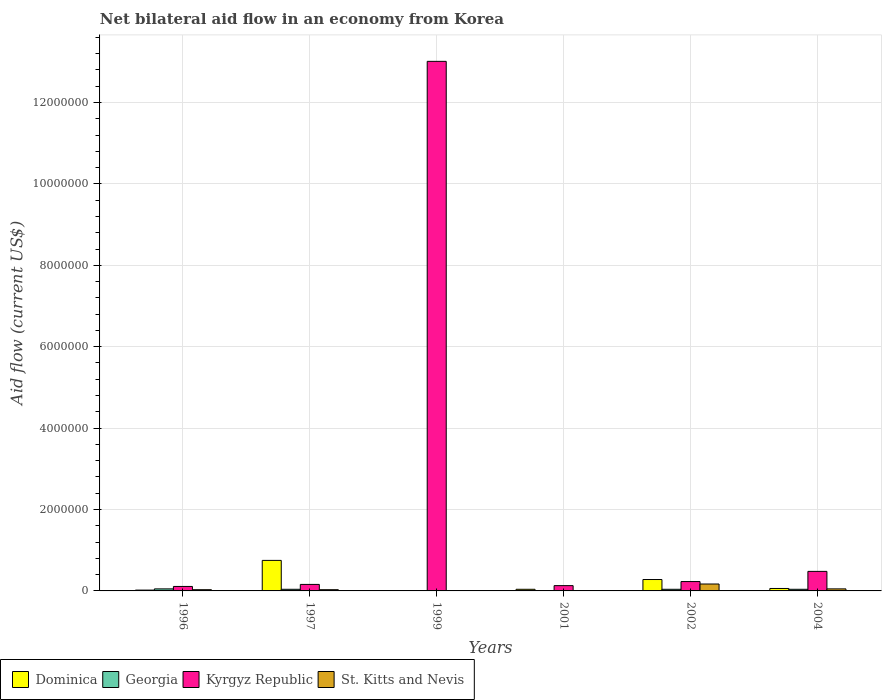How many groups of bars are there?
Your response must be concise. 6. How many bars are there on the 6th tick from the left?
Your answer should be very brief. 4. In how many cases, is the number of bars for a given year not equal to the number of legend labels?
Your answer should be very brief. 0. What is the net bilateral aid flow in St. Kitts and Nevis in 2001?
Provide a succinct answer. 10000. Across all years, what is the minimum net bilateral aid flow in Georgia?
Your answer should be very brief. 10000. What is the total net bilateral aid flow in Kyrgyz Republic in the graph?
Offer a terse response. 1.41e+07. What is the difference between the net bilateral aid flow in Kyrgyz Republic in 1999 and that in 2002?
Offer a very short reply. 1.28e+07. What is the difference between the net bilateral aid flow in Dominica in 1999 and the net bilateral aid flow in Kyrgyz Republic in 2004?
Provide a short and direct response. -4.70e+05. What is the average net bilateral aid flow in St. Kitts and Nevis per year?
Make the answer very short. 5.00e+04. In the year 1996, what is the difference between the net bilateral aid flow in Dominica and net bilateral aid flow in Georgia?
Ensure brevity in your answer.  -3.00e+04. In how many years, is the net bilateral aid flow in Dominica greater than 3200000 US$?
Offer a terse response. 0. What is the difference between the highest and the lowest net bilateral aid flow in Kyrgyz Republic?
Give a very brief answer. 1.29e+07. In how many years, is the net bilateral aid flow in St. Kitts and Nevis greater than the average net bilateral aid flow in St. Kitts and Nevis taken over all years?
Provide a short and direct response. 1. What does the 3rd bar from the left in 1999 represents?
Keep it short and to the point. Kyrgyz Republic. What does the 4th bar from the right in 1999 represents?
Keep it short and to the point. Dominica. How many years are there in the graph?
Give a very brief answer. 6. Does the graph contain any zero values?
Offer a terse response. No. How many legend labels are there?
Your response must be concise. 4. How are the legend labels stacked?
Your answer should be very brief. Horizontal. What is the title of the graph?
Your answer should be very brief. Net bilateral aid flow in an economy from Korea. Does "World" appear as one of the legend labels in the graph?
Your response must be concise. No. What is the Aid flow (current US$) in Dominica in 1996?
Provide a short and direct response. 2.00e+04. What is the Aid flow (current US$) of Georgia in 1996?
Keep it short and to the point. 5.00e+04. What is the Aid flow (current US$) of St. Kitts and Nevis in 1996?
Your answer should be very brief. 3.00e+04. What is the Aid flow (current US$) in Dominica in 1997?
Offer a terse response. 7.50e+05. What is the Aid flow (current US$) in Georgia in 1997?
Your answer should be compact. 4.00e+04. What is the Aid flow (current US$) of St. Kitts and Nevis in 1997?
Provide a short and direct response. 3.00e+04. What is the Aid flow (current US$) of Dominica in 1999?
Your response must be concise. 10000. What is the Aid flow (current US$) in Georgia in 1999?
Your response must be concise. 10000. What is the Aid flow (current US$) of Kyrgyz Republic in 1999?
Make the answer very short. 1.30e+07. What is the Aid flow (current US$) in Kyrgyz Republic in 2001?
Keep it short and to the point. 1.30e+05. What is the Aid flow (current US$) of Dominica in 2004?
Offer a very short reply. 6.00e+04. What is the Aid flow (current US$) in Georgia in 2004?
Offer a terse response. 4.00e+04. Across all years, what is the maximum Aid flow (current US$) of Dominica?
Provide a succinct answer. 7.50e+05. Across all years, what is the maximum Aid flow (current US$) of Georgia?
Provide a succinct answer. 5.00e+04. Across all years, what is the maximum Aid flow (current US$) of Kyrgyz Republic?
Make the answer very short. 1.30e+07. Across all years, what is the maximum Aid flow (current US$) in St. Kitts and Nevis?
Offer a terse response. 1.70e+05. Across all years, what is the minimum Aid flow (current US$) in Georgia?
Keep it short and to the point. 10000. What is the total Aid flow (current US$) of Dominica in the graph?
Your response must be concise. 1.16e+06. What is the total Aid flow (current US$) of Georgia in the graph?
Provide a short and direct response. 1.90e+05. What is the total Aid flow (current US$) in Kyrgyz Republic in the graph?
Offer a very short reply. 1.41e+07. What is the difference between the Aid flow (current US$) of Dominica in 1996 and that in 1997?
Make the answer very short. -7.30e+05. What is the difference between the Aid flow (current US$) in Georgia in 1996 and that in 1997?
Ensure brevity in your answer.  10000. What is the difference between the Aid flow (current US$) of St. Kitts and Nevis in 1996 and that in 1997?
Provide a succinct answer. 0. What is the difference between the Aid flow (current US$) of Georgia in 1996 and that in 1999?
Your answer should be very brief. 4.00e+04. What is the difference between the Aid flow (current US$) of Kyrgyz Republic in 1996 and that in 1999?
Your response must be concise. -1.29e+07. What is the difference between the Aid flow (current US$) in St. Kitts and Nevis in 1996 and that in 1999?
Your answer should be very brief. 2.00e+04. What is the difference between the Aid flow (current US$) in Georgia in 1996 and that in 2001?
Your answer should be compact. 4.00e+04. What is the difference between the Aid flow (current US$) of Kyrgyz Republic in 1996 and that in 2001?
Keep it short and to the point. -2.00e+04. What is the difference between the Aid flow (current US$) of St. Kitts and Nevis in 1996 and that in 2001?
Your answer should be compact. 2.00e+04. What is the difference between the Aid flow (current US$) of Dominica in 1996 and that in 2002?
Your answer should be compact. -2.60e+05. What is the difference between the Aid flow (current US$) in Georgia in 1996 and that in 2002?
Ensure brevity in your answer.  10000. What is the difference between the Aid flow (current US$) of Dominica in 1996 and that in 2004?
Ensure brevity in your answer.  -4.00e+04. What is the difference between the Aid flow (current US$) of Georgia in 1996 and that in 2004?
Your answer should be compact. 10000. What is the difference between the Aid flow (current US$) in Kyrgyz Republic in 1996 and that in 2004?
Provide a short and direct response. -3.70e+05. What is the difference between the Aid flow (current US$) of St. Kitts and Nevis in 1996 and that in 2004?
Provide a succinct answer. -2.00e+04. What is the difference between the Aid flow (current US$) of Dominica in 1997 and that in 1999?
Keep it short and to the point. 7.40e+05. What is the difference between the Aid flow (current US$) in Kyrgyz Republic in 1997 and that in 1999?
Offer a very short reply. -1.28e+07. What is the difference between the Aid flow (current US$) of St. Kitts and Nevis in 1997 and that in 1999?
Provide a short and direct response. 2.00e+04. What is the difference between the Aid flow (current US$) in Dominica in 1997 and that in 2001?
Your response must be concise. 7.10e+05. What is the difference between the Aid flow (current US$) in St. Kitts and Nevis in 1997 and that in 2001?
Make the answer very short. 2.00e+04. What is the difference between the Aid flow (current US$) of Georgia in 1997 and that in 2002?
Give a very brief answer. 0. What is the difference between the Aid flow (current US$) in Dominica in 1997 and that in 2004?
Offer a terse response. 6.90e+05. What is the difference between the Aid flow (current US$) of Kyrgyz Republic in 1997 and that in 2004?
Offer a terse response. -3.20e+05. What is the difference between the Aid flow (current US$) in St. Kitts and Nevis in 1997 and that in 2004?
Provide a short and direct response. -2.00e+04. What is the difference between the Aid flow (current US$) in Dominica in 1999 and that in 2001?
Your response must be concise. -3.00e+04. What is the difference between the Aid flow (current US$) in Kyrgyz Republic in 1999 and that in 2001?
Give a very brief answer. 1.29e+07. What is the difference between the Aid flow (current US$) of St. Kitts and Nevis in 1999 and that in 2001?
Your response must be concise. 0. What is the difference between the Aid flow (current US$) in Georgia in 1999 and that in 2002?
Your answer should be compact. -3.00e+04. What is the difference between the Aid flow (current US$) of Kyrgyz Republic in 1999 and that in 2002?
Your answer should be compact. 1.28e+07. What is the difference between the Aid flow (current US$) in Kyrgyz Republic in 1999 and that in 2004?
Provide a succinct answer. 1.25e+07. What is the difference between the Aid flow (current US$) of Georgia in 2001 and that in 2002?
Keep it short and to the point. -3.00e+04. What is the difference between the Aid flow (current US$) in St. Kitts and Nevis in 2001 and that in 2002?
Your answer should be very brief. -1.60e+05. What is the difference between the Aid flow (current US$) in Kyrgyz Republic in 2001 and that in 2004?
Your response must be concise. -3.50e+05. What is the difference between the Aid flow (current US$) of St. Kitts and Nevis in 2001 and that in 2004?
Your answer should be compact. -4.00e+04. What is the difference between the Aid flow (current US$) of Dominica in 2002 and that in 2004?
Your answer should be very brief. 2.20e+05. What is the difference between the Aid flow (current US$) in Georgia in 2002 and that in 2004?
Provide a short and direct response. 0. What is the difference between the Aid flow (current US$) in St. Kitts and Nevis in 2002 and that in 2004?
Provide a short and direct response. 1.20e+05. What is the difference between the Aid flow (current US$) of Dominica in 1996 and the Aid flow (current US$) of Georgia in 1997?
Keep it short and to the point. -2.00e+04. What is the difference between the Aid flow (current US$) in Dominica in 1996 and the Aid flow (current US$) in Kyrgyz Republic in 1997?
Provide a succinct answer. -1.40e+05. What is the difference between the Aid flow (current US$) of Georgia in 1996 and the Aid flow (current US$) of Kyrgyz Republic in 1997?
Ensure brevity in your answer.  -1.10e+05. What is the difference between the Aid flow (current US$) of Georgia in 1996 and the Aid flow (current US$) of St. Kitts and Nevis in 1997?
Your answer should be compact. 2.00e+04. What is the difference between the Aid flow (current US$) of Dominica in 1996 and the Aid flow (current US$) of Kyrgyz Republic in 1999?
Your answer should be compact. -1.30e+07. What is the difference between the Aid flow (current US$) in Georgia in 1996 and the Aid flow (current US$) in Kyrgyz Republic in 1999?
Keep it short and to the point. -1.30e+07. What is the difference between the Aid flow (current US$) of Dominica in 1996 and the Aid flow (current US$) of Kyrgyz Republic in 2001?
Your response must be concise. -1.10e+05. What is the difference between the Aid flow (current US$) in Georgia in 1996 and the Aid flow (current US$) in St. Kitts and Nevis in 2001?
Provide a succinct answer. 4.00e+04. What is the difference between the Aid flow (current US$) in Georgia in 1996 and the Aid flow (current US$) in Kyrgyz Republic in 2002?
Your answer should be very brief. -1.80e+05. What is the difference between the Aid flow (current US$) of Georgia in 1996 and the Aid flow (current US$) of St. Kitts and Nevis in 2002?
Your answer should be compact. -1.20e+05. What is the difference between the Aid flow (current US$) of Kyrgyz Republic in 1996 and the Aid flow (current US$) of St. Kitts and Nevis in 2002?
Your answer should be compact. -6.00e+04. What is the difference between the Aid flow (current US$) in Dominica in 1996 and the Aid flow (current US$) in Kyrgyz Republic in 2004?
Provide a succinct answer. -4.60e+05. What is the difference between the Aid flow (current US$) of Georgia in 1996 and the Aid flow (current US$) of Kyrgyz Republic in 2004?
Offer a terse response. -4.30e+05. What is the difference between the Aid flow (current US$) of Dominica in 1997 and the Aid flow (current US$) of Georgia in 1999?
Keep it short and to the point. 7.40e+05. What is the difference between the Aid flow (current US$) in Dominica in 1997 and the Aid flow (current US$) in Kyrgyz Republic in 1999?
Offer a very short reply. -1.23e+07. What is the difference between the Aid flow (current US$) of Dominica in 1997 and the Aid flow (current US$) of St. Kitts and Nevis in 1999?
Your response must be concise. 7.40e+05. What is the difference between the Aid flow (current US$) in Georgia in 1997 and the Aid flow (current US$) in Kyrgyz Republic in 1999?
Ensure brevity in your answer.  -1.30e+07. What is the difference between the Aid flow (current US$) of Dominica in 1997 and the Aid flow (current US$) of Georgia in 2001?
Provide a succinct answer. 7.40e+05. What is the difference between the Aid flow (current US$) of Dominica in 1997 and the Aid flow (current US$) of Kyrgyz Republic in 2001?
Your answer should be very brief. 6.20e+05. What is the difference between the Aid flow (current US$) in Dominica in 1997 and the Aid flow (current US$) in St. Kitts and Nevis in 2001?
Ensure brevity in your answer.  7.40e+05. What is the difference between the Aid flow (current US$) of Georgia in 1997 and the Aid flow (current US$) of Kyrgyz Republic in 2001?
Offer a terse response. -9.00e+04. What is the difference between the Aid flow (current US$) of Dominica in 1997 and the Aid flow (current US$) of Georgia in 2002?
Provide a short and direct response. 7.10e+05. What is the difference between the Aid flow (current US$) in Dominica in 1997 and the Aid flow (current US$) in Kyrgyz Republic in 2002?
Offer a terse response. 5.20e+05. What is the difference between the Aid flow (current US$) in Dominica in 1997 and the Aid flow (current US$) in St. Kitts and Nevis in 2002?
Your response must be concise. 5.80e+05. What is the difference between the Aid flow (current US$) of Georgia in 1997 and the Aid flow (current US$) of St. Kitts and Nevis in 2002?
Offer a terse response. -1.30e+05. What is the difference between the Aid flow (current US$) in Kyrgyz Republic in 1997 and the Aid flow (current US$) in St. Kitts and Nevis in 2002?
Offer a terse response. -10000. What is the difference between the Aid flow (current US$) of Dominica in 1997 and the Aid flow (current US$) of Georgia in 2004?
Make the answer very short. 7.10e+05. What is the difference between the Aid flow (current US$) in Georgia in 1997 and the Aid flow (current US$) in Kyrgyz Republic in 2004?
Give a very brief answer. -4.40e+05. What is the difference between the Aid flow (current US$) in Georgia in 1997 and the Aid flow (current US$) in St. Kitts and Nevis in 2004?
Offer a very short reply. -10000. What is the difference between the Aid flow (current US$) of Kyrgyz Republic in 1997 and the Aid flow (current US$) of St. Kitts and Nevis in 2004?
Offer a terse response. 1.10e+05. What is the difference between the Aid flow (current US$) in Dominica in 1999 and the Aid flow (current US$) in Kyrgyz Republic in 2001?
Keep it short and to the point. -1.20e+05. What is the difference between the Aid flow (current US$) of Kyrgyz Republic in 1999 and the Aid flow (current US$) of St. Kitts and Nevis in 2001?
Offer a very short reply. 1.30e+07. What is the difference between the Aid flow (current US$) in Dominica in 1999 and the Aid flow (current US$) in St. Kitts and Nevis in 2002?
Offer a very short reply. -1.60e+05. What is the difference between the Aid flow (current US$) of Georgia in 1999 and the Aid flow (current US$) of Kyrgyz Republic in 2002?
Ensure brevity in your answer.  -2.20e+05. What is the difference between the Aid flow (current US$) of Georgia in 1999 and the Aid flow (current US$) of St. Kitts and Nevis in 2002?
Provide a short and direct response. -1.60e+05. What is the difference between the Aid flow (current US$) of Kyrgyz Republic in 1999 and the Aid flow (current US$) of St. Kitts and Nevis in 2002?
Offer a very short reply. 1.28e+07. What is the difference between the Aid flow (current US$) in Dominica in 1999 and the Aid flow (current US$) in Georgia in 2004?
Offer a very short reply. -3.00e+04. What is the difference between the Aid flow (current US$) in Dominica in 1999 and the Aid flow (current US$) in Kyrgyz Republic in 2004?
Provide a succinct answer. -4.70e+05. What is the difference between the Aid flow (current US$) of Dominica in 1999 and the Aid flow (current US$) of St. Kitts and Nevis in 2004?
Your response must be concise. -4.00e+04. What is the difference between the Aid flow (current US$) of Georgia in 1999 and the Aid flow (current US$) of Kyrgyz Republic in 2004?
Your answer should be very brief. -4.70e+05. What is the difference between the Aid flow (current US$) in Kyrgyz Republic in 1999 and the Aid flow (current US$) in St. Kitts and Nevis in 2004?
Your answer should be compact. 1.30e+07. What is the difference between the Aid flow (current US$) of Dominica in 2001 and the Aid flow (current US$) of Georgia in 2002?
Provide a short and direct response. 0. What is the difference between the Aid flow (current US$) of Dominica in 2001 and the Aid flow (current US$) of Kyrgyz Republic in 2002?
Your answer should be very brief. -1.90e+05. What is the difference between the Aid flow (current US$) in Georgia in 2001 and the Aid flow (current US$) in Kyrgyz Republic in 2002?
Give a very brief answer. -2.20e+05. What is the difference between the Aid flow (current US$) in Kyrgyz Republic in 2001 and the Aid flow (current US$) in St. Kitts and Nevis in 2002?
Provide a short and direct response. -4.00e+04. What is the difference between the Aid flow (current US$) in Dominica in 2001 and the Aid flow (current US$) in Georgia in 2004?
Your answer should be compact. 0. What is the difference between the Aid flow (current US$) of Dominica in 2001 and the Aid flow (current US$) of Kyrgyz Republic in 2004?
Provide a short and direct response. -4.40e+05. What is the difference between the Aid flow (current US$) in Georgia in 2001 and the Aid flow (current US$) in Kyrgyz Republic in 2004?
Make the answer very short. -4.70e+05. What is the difference between the Aid flow (current US$) in Georgia in 2001 and the Aid flow (current US$) in St. Kitts and Nevis in 2004?
Keep it short and to the point. -4.00e+04. What is the difference between the Aid flow (current US$) of Kyrgyz Republic in 2001 and the Aid flow (current US$) of St. Kitts and Nevis in 2004?
Your response must be concise. 8.00e+04. What is the difference between the Aid flow (current US$) of Dominica in 2002 and the Aid flow (current US$) of St. Kitts and Nevis in 2004?
Keep it short and to the point. 2.30e+05. What is the difference between the Aid flow (current US$) of Georgia in 2002 and the Aid flow (current US$) of Kyrgyz Republic in 2004?
Provide a short and direct response. -4.40e+05. What is the difference between the Aid flow (current US$) of Georgia in 2002 and the Aid flow (current US$) of St. Kitts and Nevis in 2004?
Your answer should be compact. -10000. What is the average Aid flow (current US$) in Dominica per year?
Provide a succinct answer. 1.93e+05. What is the average Aid flow (current US$) in Georgia per year?
Offer a terse response. 3.17e+04. What is the average Aid flow (current US$) in Kyrgyz Republic per year?
Offer a terse response. 2.35e+06. What is the average Aid flow (current US$) in St. Kitts and Nevis per year?
Ensure brevity in your answer.  5.00e+04. In the year 1996, what is the difference between the Aid flow (current US$) of Dominica and Aid flow (current US$) of Kyrgyz Republic?
Make the answer very short. -9.00e+04. In the year 1996, what is the difference between the Aid flow (current US$) in Georgia and Aid flow (current US$) in Kyrgyz Republic?
Ensure brevity in your answer.  -6.00e+04. In the year 1996, what is the difference between the Aid flow (current US$) of Georgia and Aid flow (current US$) of St. Kitts and Nevis?
Your response must be concise. 2.00e+04. In the year 1996, what is the difference between the Aid flow (current US$) of Kyrgyz Republic and Aid flow (current US$) of St. Kitts and Nevis?
Make the answer very short. 8.00e+04. In the year 1997, what is the difference between the Aid flow (current US$) of Dominica and Aid flow (current US$) of Georgia?
Your answer should be compact. 7.10e+05. In the year 1997, what is the difference between the Aid flow (current US$) of Dominica and Aid flow (current US$) of Kyrgyz Republic?
Offer a very short reply. 5.90e+05. In the year 1997, what is the difference between the Aid flow (current US$) in Dominica and Aid flow (current US$) in St. Kitts and Nevis?
Provide a succinct answer. 7.20e+05. In the year 1997, what is the difference between the Aid flow (current US$) of Georgia and Aid flow (current US$) of St. Kitts and Nevis?
Provide a short and direct response. 10000. In the year 1997, what is the difference between the Aid flow (current US$) in Kyrgyz Republic and Aid flow (current US$) in St. Kitts and Nevis?
Provide a short and direct response. 1.30e+05. In the year 1999, what is the difference between the Aid flow (current US$) in Dominica and Aid flow (current US$) in Georgia?
Provide a succinct answer. 0. In the year 1999, what is the difference between the Aid flow (current US$) in Dominica and Aid flow (current US$) in Kyrgyz Republic?
Your response must be concise. -1.30e+07. In the year 1999, what is the difference between the Aid flow (current US$) of Dominica and Aid flow (current US$) of St. Kitts and Nevis?
Ensure brevity in your answer.  0. In the year 1999, what is the difference between the Aid flow (current US$) in Georgia and Aid flow (current US$) in Kyrgyz Republic?
Give a very brief answer. -1.30e+07. In the year 1999, what is the difference between the Aid flow (current US$) in Kyrgyz Republic and Aid flow (current US$) in St. Kitts and Nevis?
Ensure brevity in your answer.  1.30e+07. In the year 2001, what is the difference between the Aid flow (current US$) in Dominica and Aid flow (current US$) in Georgia?
Ensure brevity in your answer.  3.00e+04. In the year 2001, what is the difference between the Aid flow (current US$) of Dominica and Aid flow (current US$) of Kyrgyz Republic?
Keep it short and to the point. -9.00e+04. In the year 2001, what is the difference between the Aid flow (current US$) of Georgia and Aid flow (current US$) of Kyrgyz Republic?
Keep it short and to the point. -1.20e+05. In the year 2001, what is the difference between the Aid flow (current US$) of Kyrgyz Republic and Aid flow (current US$) of St. Kitts and Nevis?
Your response must be concise. 1.20e+05. In the year 2002, what is the difference between the Aid flow (current US$) of Dominica and Aid flow (current US$) of Georgia?
Provide a short and direct response. 2.40e+05. In the year 2002, what is the difference between the Aid flow (current US$) in Dominica and Aid flow (current US$) in Kyrgyz Republic?
Offer a very short reply. 5.00e+04. In the year 2002, what is the difference between the Aid flow (current US$) in Dominica and Aid flow (current US$) in St. Kitts and Nevis?
Provide a short and direct response. 1.10e+05. In the year 2002, what is the difference between the Aid flow (current US$) in Georgia and Aid flow (current US$) in St. Kitts and Nevis?
Your answer should be compact. -1.30e+05. In the year 2004, what is the difference between the Aid flow (current US$) in Dominica and Aid flow (current US$) in Georgia?
Offer a terse response. 2.00e+04. In the year 2004, what is the difference between the Aid flow (current US$) in Dominica and Aid flow (current US$) in Kyrgyz Republic?
Offer a terse response. -4.20e+05. In the year 2004, what is the difference between the Aid flow (current US$) in Georgia and Aid flow (current US$) in Kyrgyz Republic?
Ensure brevity in your answer.  -4.40e+05. What is the ratio of the Aid flow (current US$) in Dominica in 1996 to that in 1997?
Your answer should be compact. 0.03. What is the ratio of the Aid flow (current US$) in Kyrgyz Republic in 1996 to that in 1997?
Your response must be concise. 0.69. What is the ratio of the Aid flow (current US$) of Georgia in 1996 to that in 1999?
Give a very brief answer. 5. What is the ratio of the Aid flow (current US$) in Kyrgyz Republic in 1996 to that in 1999?
Offer a terse response. 0.01. What is the ratio of the Aid flow (current US$) in Dominica in 1996 to that in 2001?
Keep it short and to the point. 0.5. What is the ratio of the Aid flow (current US$) in Georgia in 1996 to that in 2001?
Offer a very short reply. 5. What is the ratio of the Aid flow (current US$) of Kyrgyz Republic in 1996 to that in 2001?
Provide a short and direct response. 0.85. What is the ratio of the Aid flow (current US$) of St. Kitts and Nevis in 1996 to that in 2001?
Your response must be concise. 3. What is the ratio of the Aid flow (current US$) in Dominica in 1996 to that in 2002?
Ensure brevity in your answer.  0.07. What is the ratio of the Aid flow (current US$) in Georgia in 1996 to that in 2002?
Provide a succinct answer. 1.25. What is the ratio of the Aid flow (current US$) in Kyrgyz Republic in 1996 to that in 2002?
Provide a succinct answer. 0.48. What is the ratio of the Aid flow (current US$) of St. Kitts and Nevis in 1996 to that in 2002?
Provide a short and direct response. 0.18. What is the ratio of the Aid flow (current US$) in Kyrgyz Republic in 1996 to that in 2004?
Keep it short and to the point. 0.23. What is the ratio of the Aid flow (current US$) of St. Kitts and Nevis in 1996 to that in 2004?
Your answer should be very brief. 0.6. What is the ratio of the Aid flow (current US$) in Kyrgyz Republic in 1997 to that in 1999?
Keep it short and to the point. 0.01. What is the ratio of the Aid flow (current US$) in St. Kitts and Nevis in 1997 to that in 1999?
Your response must be concise. 3. What is the ratio of the Aid flow (current US$) of Dominica in 1997 to that in 2001?
Provide a short and direct response. 18.75. What is the ratio of the Aid flow (current US$) of Kyrgyz Republic in 1997 to that in 2001?
Provide a short and direct response. 1.23. What is the ratio of the Aid flow (current US$) of St. Kitts and Nevis in 1997 to that in 2001?
Your response must be concise. 3. What is the ratio of the Aid flow (current US$) of Dominica in 1997 to that in 2002?
Your answer should be very brief. 2.68. What is the ratio of the Aid flow (current US$) in Georgia in 1997 to that in 2002?
Provide a short and direct response. 1. What is the ratio of the Aid flow (current US$) in Kyrgyz Republic in 1997 to that in 2002?
Keep it short and to the point. 0.7. What is the ratio of the Aid flow (current US$) of St. Kitts and Nevis in 1997 to that in 2002?
Provide a short and direct response. 0.18. What is the ratio of the Aid flow (current US$) in Dominica in 1997 to that in 2004?
Your response must be concise. 12.5. What is the ratio of the Aid flow (current US$) of Kyrgyz Republic in 1997 to that in 2004?
Your answer should be very brief. 0.33. What is the ratio of the Aid flow (current US$) of Georgia in 1999 to that in 2001?
Keep it short and to the point. 1. What is the ratio of the Aid flow (current US$) in Kyrgyz Republic in 1999 to that in 2001?
Keep it short and to the point. 100.08. What is the ratio of the Aid flow (current US$) of St. Kitts and Nevis in 1999 to that in 2001?
Make the answer very short. 1. What is the ratio of the Aid flow (current US$) in Dominica in 1999 to that in 2002?
Offer a very short reply. 0.04. What is the ratio of the Aid flow (current US$) of Kyrgyz Republic in 1999 to that in 2002?
Offer a very short reply. 56.57. What is the ratio of the Aid flow (current US$) of St. Kitts and Nevis in 1999 to that in 2002?
Your response must be concise. 0.06. What is the ratio of the Aid flow (current US$) of Kyrgyz Republic in 1999 to that in 2004?
Your response must be concise. 27.1. What is the ratio of the Aid flow (current US$) of Dominica in 2001 to that in 2002?
Provide a succinct answer. 0.14. What is the ratio of the Aid flow (current US$) of Georgia in 2001 to that in 2002?
Offer a terse response. 0.25. What is the ratio of the Aid flow (current US$) of Kyrgyz Republic in 2001 to that in 2002?
Offer a terse response. 0.57. What is the ratio of the Aid flow (current US$) of St. Kitts and Nevis in 2001 to that in 2002?
Ensure brevity in your answer.  0.06. What is the ratio of the Aid flow (current US$) in Dominica in 2001 to that in 2004?
Your answer should be compact. 0.67. What is the ratio of the Aid flow (current US$) of Georgia in 2001 to that in 2004?
Your response must be concise. 0.25. What is the ratio of the Aid flow (current US$) in Kyrgyz Republic in 2001 to that in 2004?
Give a very brief answer. 0.27. What is the ratio of the Aid flow (current US$) of Dominica in 2002 to that in 2004?
Your answer should be very brief. 4.67. What is the ratio of the Aid flow (current US$) of Kyrgyz Republic in 2002 to that in 2004?
Your answer should be compact. 0.48. What is the ratio of the Aid flow (current US$) of St. Kitts and Nevis in 2002 to that in 2004?
Your answer should be compact. 3.4. What is the difference between the highest and the second highest Aid flow (current US$) of Dominica?
Your answer should be compact. 4.70e+05. What is the difference between the highest and the second highest Aid flow (current US$) of Georgia?
Offer a terse response. 10000. What is the difference between the highest and the second highest Aid flow (current US$) in Kyrgyz Republic?
Keep it short and to the point. 1.25e+07. What is the difference between the highest and the second highest Aid flow (current US$) of St. Kitts and Nevis?
Your answer should be compact. 1.20e+05. What is the difference between the highest and the lowest Aid flow (current US$) in Dominica?
Provide a short and direct response. 7.40e+05. What is the difference between the highest and the lowest Aid flow (current US$) of Kyrgyz Republic?
Make the answer very short. 1.29e+07. What is the difference between the highest and the lowest Aid flow (current US$) in St. Kitts and Nevis?
Keep it short and to the point. 1.60e+05. 